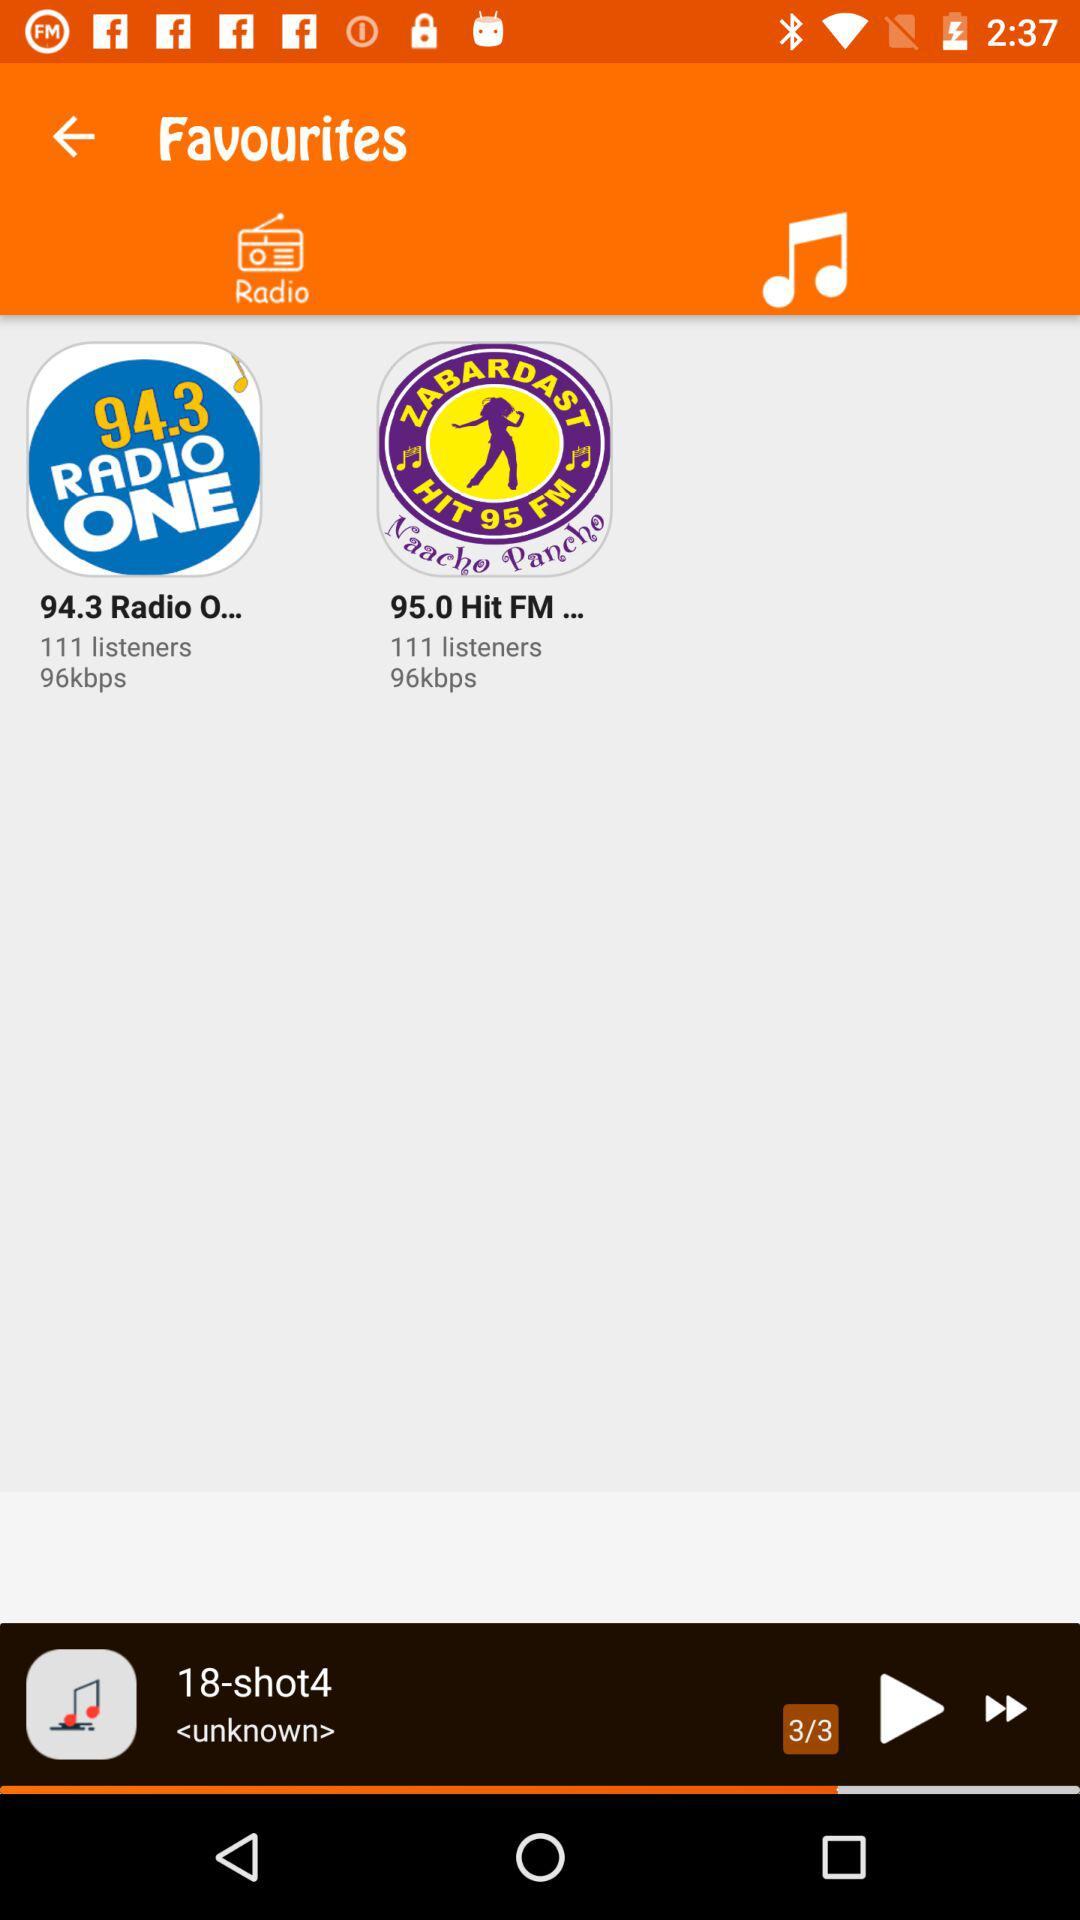What song is playing? The song that is playing is "18-shot4". 